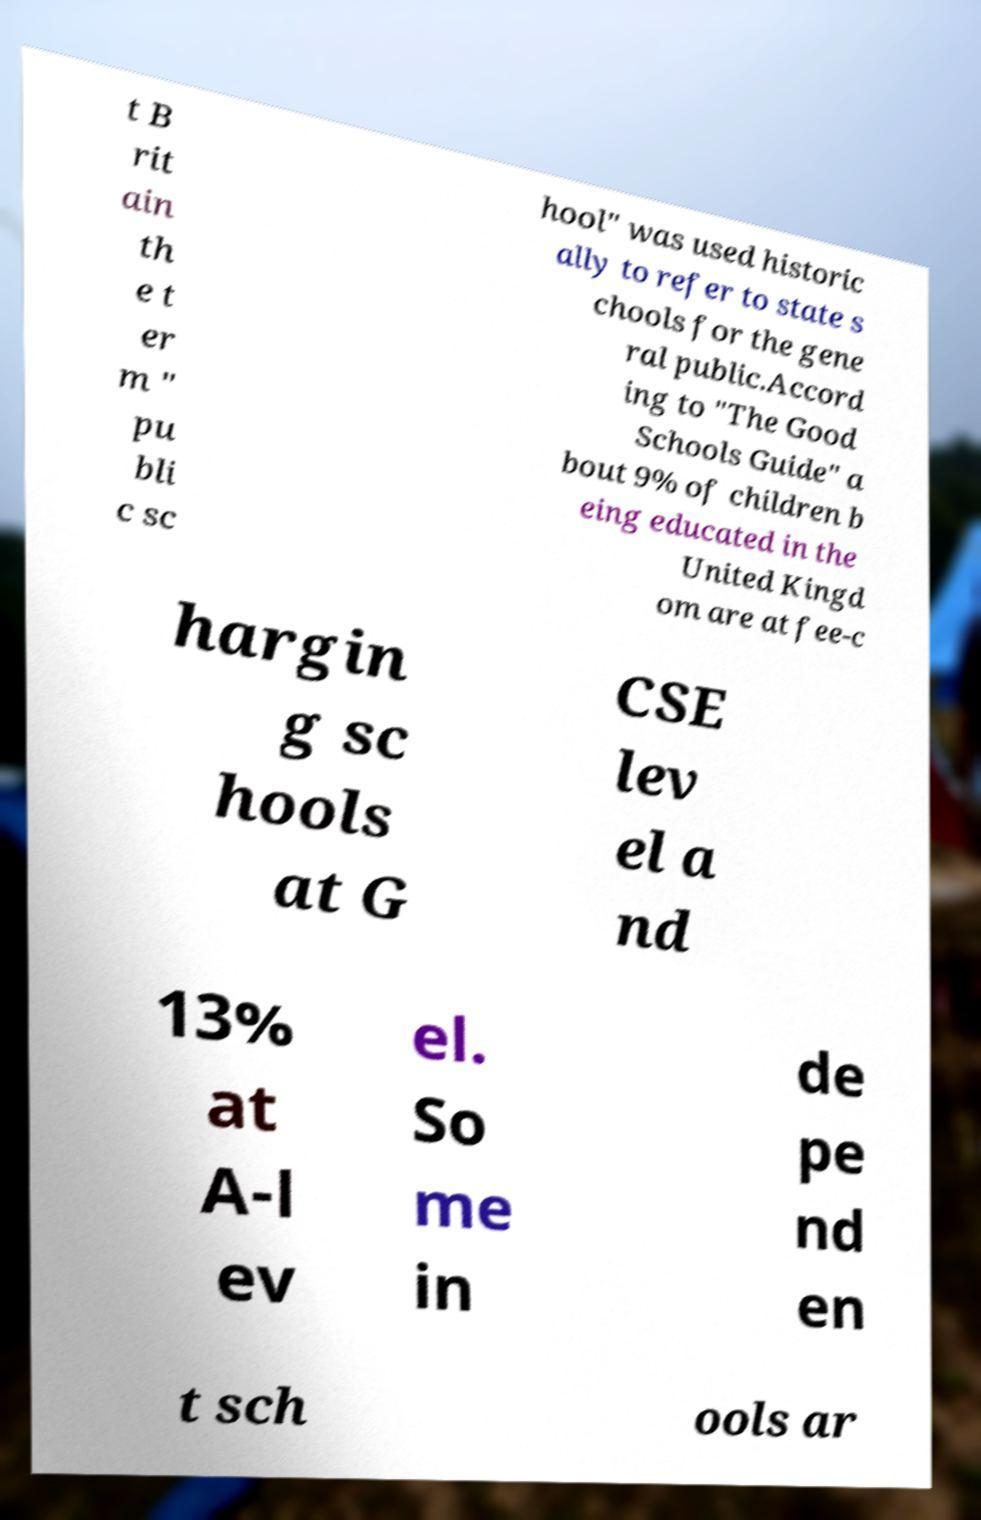Can you accurately transcribe the text from the provided image for me? t B rit ain th e t er m " pu bli c sc hool" was used historic ally to refer to state s chools for the gene ral public.Accord ing to "The Good Schools Guide" a bout 9% of children b eing educated in the United Kingd om are at fee-c hargin g sc hools at G CSE lev el a nd 13% at A-l ev el. So me in de pe nd en t sch ools ar 